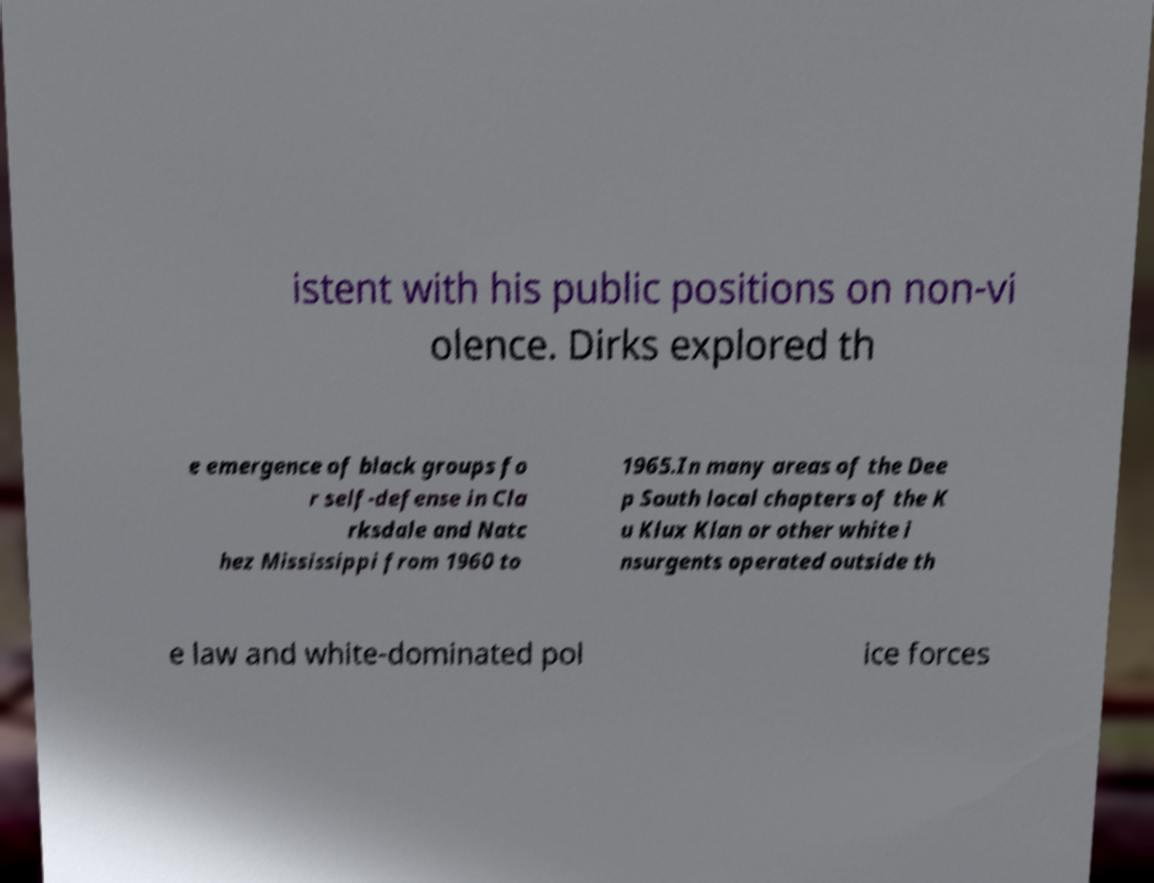I need the written content from this picture converted into text. Can you do that? istent with his public positions on non-vi olence. Dirks explored th e emergence of black groups fo r self-defense in Cla rksdale and Natc hez Mississippi from 1960 to 1965.In many areas of the Dee p South local chapters of the K u Klux Klan or other white i nsurgents operated outside th e law and white-dominated pol ice forces 